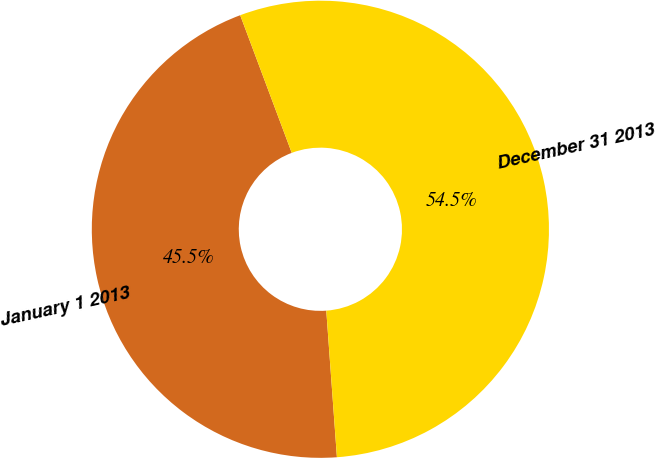Convert chart to OTSL. <chart><loc_0><loc_0><loc_500><loc_500><pie_chart><fcel>January 1 2013<fcel>December 31 2013<nl><fcel>45.45%<fcel>54.55%<nl></chart> 